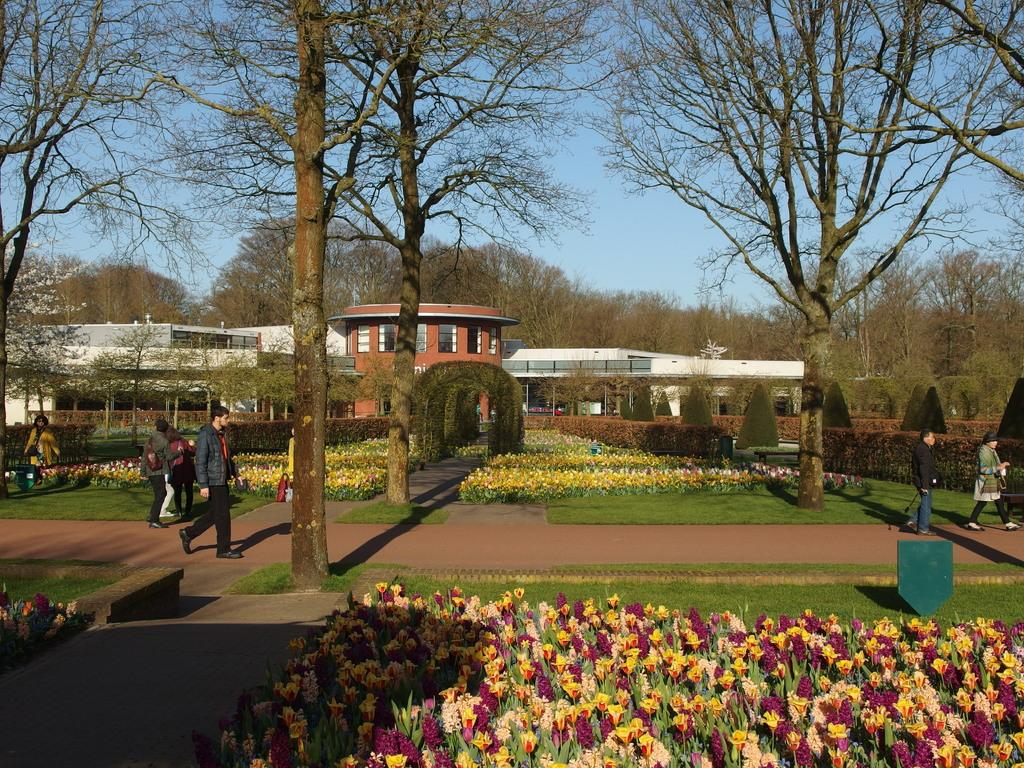What type of structure is visible in the image? There is a building in the image. What other natural elements can be seen in the image? There are trees and flower plants visible in the image. What are the people in the image doing? There are people walking in the image. What is the ground covered with in the image? There is grass on the ground in the image. What is the color of the sky in the image? The sky is blue in the image. Who is the owner of the boot seen in the image? There is no boot present in the image. 